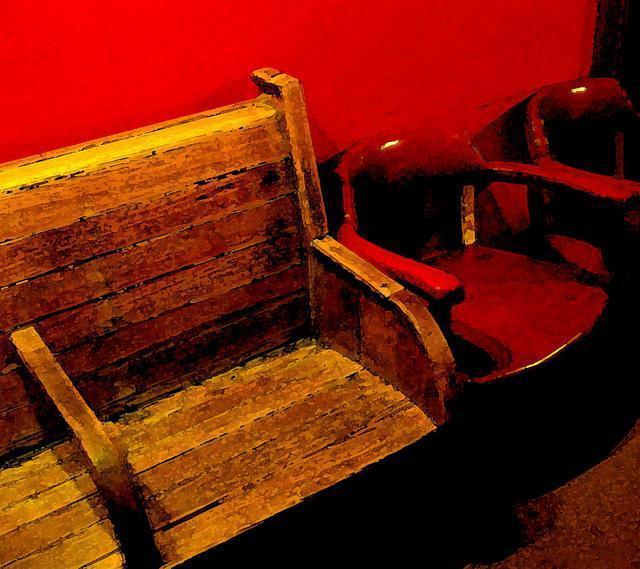How many chairs are there?
Give a very brief answer. 2. How many people in this picture are wearing shirts?
Give a very brief answer. 0. 